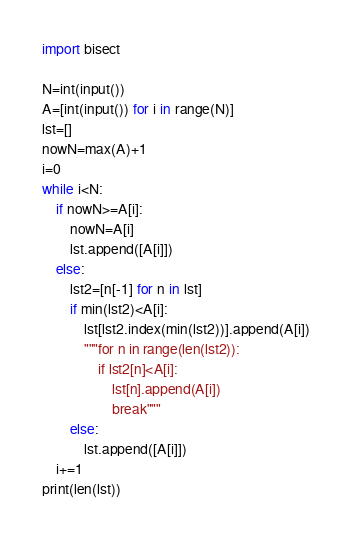Convert code to text. <code><loc_0><loc_0><loc_500><loc_500><_Python_>import bisect

N=int(input())
A=[int(input()) for i in range(N)]
lst=[]
nowN=max(A)+1
i=0
while i<N:
    if nowN>=A[i]:
        nowN=A[i]
        lst.append([A[i]])
    else:
        lst2=[n[-1] for n in lst]
        if min(lst2)<A[i]:
            lst[lst2.index(min(lst2))].append(A[i])
            """for n in range(len(lst2)):
                if lst2[n]<A[i]:
                    lst[n].append(A[i])
                    break"""
        else:
            lst.append([A[i]])
    i+=1
print(len(lst))
</code> 